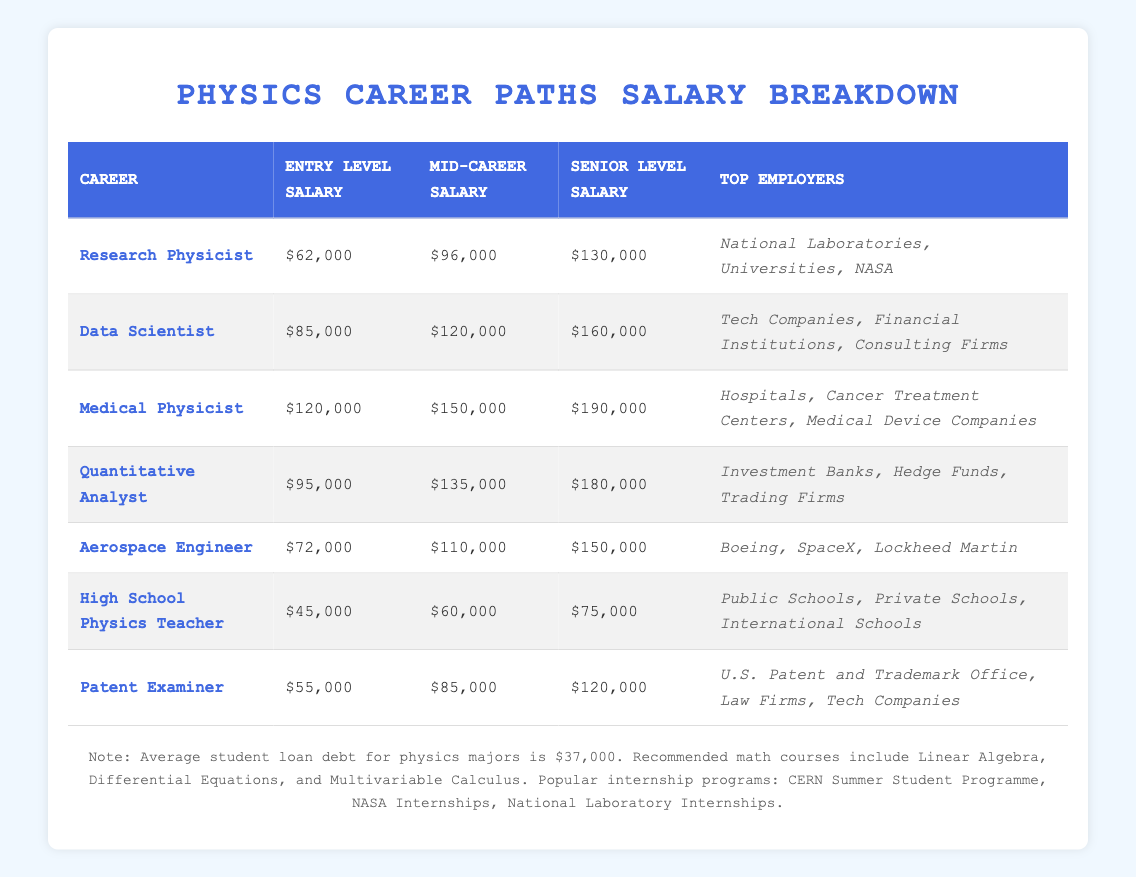What is the entry-level salary for a Medical Physicist? The entry-level salary for a Medical Physicist is stated directly in the table under the "Entry Level Salary" column for that career. It shows as $120,000.
Answer: $120,000 Which career path has the highest mid-career salary? To determine the highest mid-career salary, we compare the mid-career salaries from all career paths in the table. The Medical Physicist has a mid-career salary of $150,000, which is greater than all other listed salaries.
Answer: Medical Physicist How much more does a Data Scientist earn than a High School Physics Teacher at the mid-career level? We find the mid-career salaries for both careers from the table. The mid-career salary for a Data Scientist is $120,000 and for a High School Physics Teacher, it is $60,000. The difference is calculated as $120,000 - $60,000 = $60,000.
Answer: $60,000 Are there any physics-related careers that have an entry-level salary below $60,000? By reviewing the "Entry Level Salary" column, we see the salaries for the careers listed. The only entry-level salary below $60,000 is for High School Physics Teacher, which is $45,000 and for Patent Examiner, which is $55,000. Thus, the answer is yes.
Answer: Yes What is the average senior-level salary across all the career paths? To calculate the average senior-level salary, we first sum up all the senior-level salaries: $130,000 (Research Physicist) + $160,000 (Data Scientist) + $190,000 (Medical Physicist) + $180,000 (Quantitative Analyst) + $150,000 (Aerospace Engineer) + $75,000 (High School Physics Teacher) + $120,000 (Patent Examiner) = $1,005,000. Then, we divide this by the number of career paths, which is 7. Therefore, the average is $1,005,000 / 7 = approximately $143,571.
Answer: $143,571 